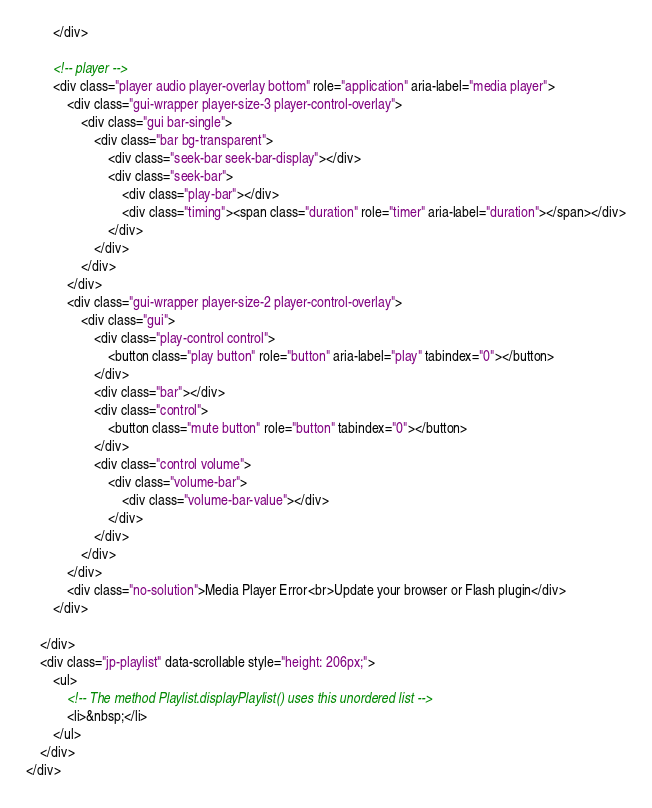<code> <loc_0><loc_0><loc_500><loc_500><_HTML_>        </div>

        <!-- player -->
        <div class="player audio player-overlay bottom" role="application" aria-label="media player">
            <div class="gui-wrapper player-size-3 player-control-overlay">
                <div class="gui bar-single">
                    <div class="bar bg-transparent">
                        <div class="seek-bar seek-bar-display"></div>
                        <div class="seek-bar">
                            <div class="play-bar"></div>
                            <div class="timing"><span class="duration" role="timer" aria-label="duration"></span></div>
                        </div>
                    </div>
                </div>
            </div>
            <div class="gui-wrapper player-size-2 player-control-overlay">
                <div class="gui">
                    <div class="play-control control">
                        <button class="play button" role="button" aria-label="play" tabindex="0"></button>
                    </div>
                    <div class="bar"></div>
                    <div class="control">
                        <button class="mute button" role="button" tabindex="0"></button>
                    </div>
                    <div class="control volume">
                        <div class="volume-bar">
                            <div class="volume-bar-value"></div>
                        </div>
                    </div>
                </div>
            </div>
            <div class="no-solution">Media Player Error<br>Update your browser or Flash plugin</div>
        </div>

    </div>
    <div class="jp-playlist" data-scrollable style="height: 206px;">
        <ul>
            <!-- The method Playlist.displayPlaylist() uses this unordered list -->
            <li>&nbsp;</li>
        </ul>
    </div>
</div></code> 